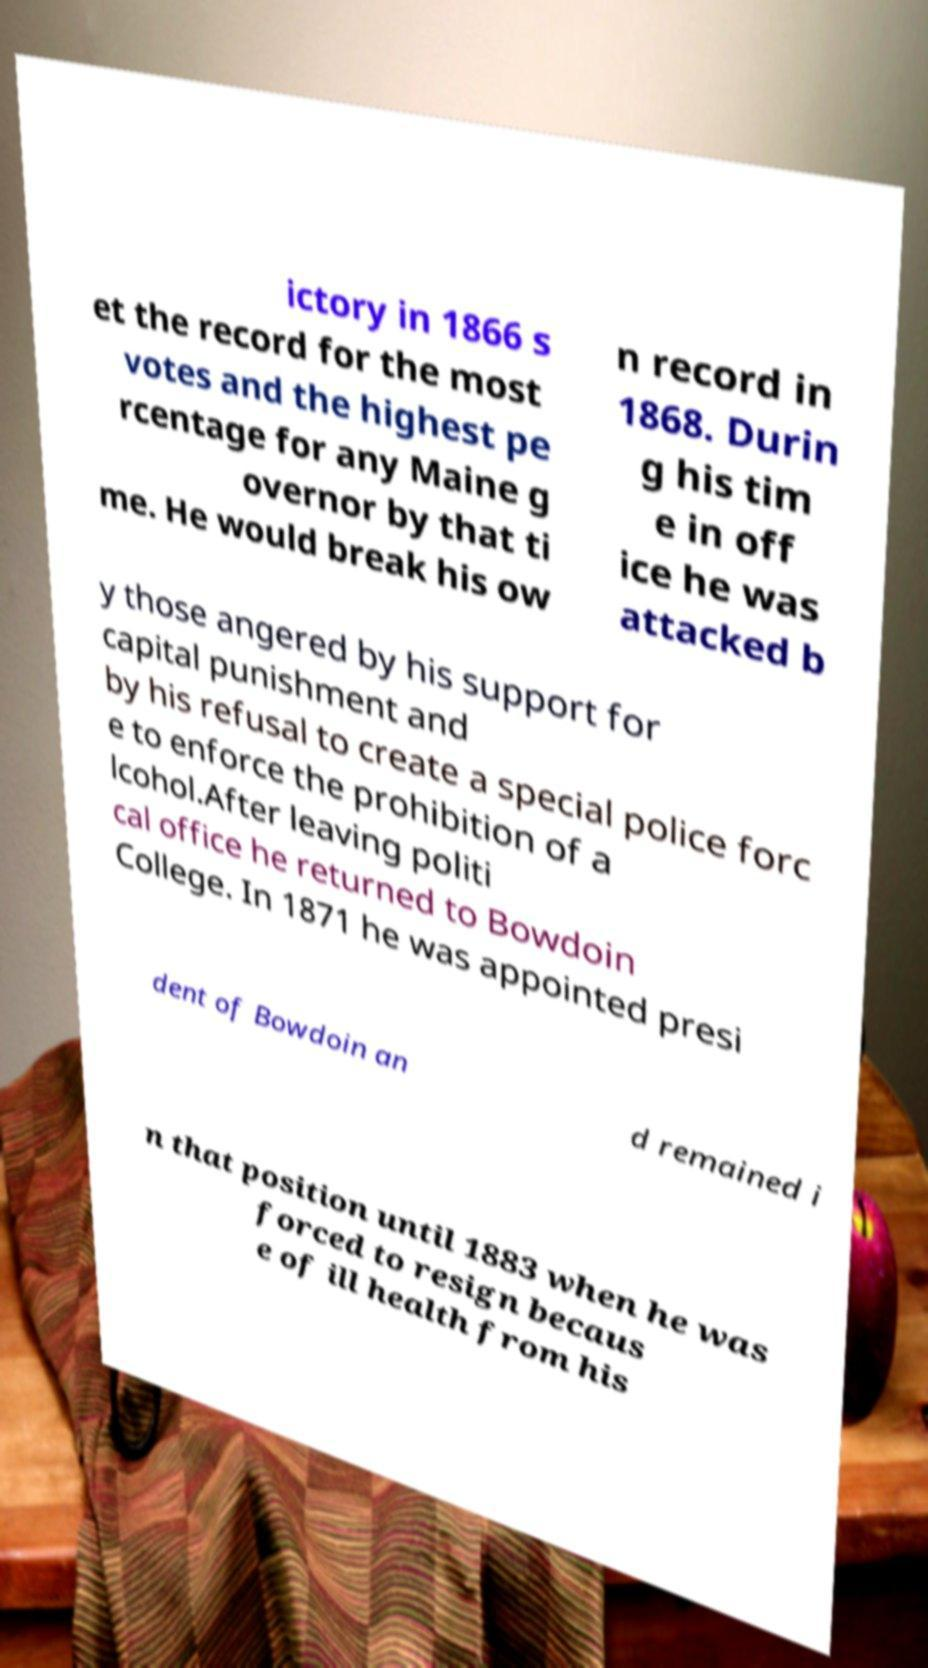Can you read and provide the text displayed in the image?This photo seems to have some interesting text. Can you extract and type it out for me? ictory in 1866 s et the record for the most votes and the highest pe rcentage for any Maine g overnor by that ti me. He would break his ow n record in 1868. Durin g his tim e in off ice he was attacked b y those angered by his support for capital punishment and by his refusal to create a special police forc e to enforce the prohibition of a lcohol.After leaving politi cal office he returned to Bowdoin College. In 1871 he was appointed presi dent of Bowdoin an d remained i n that position until 1883 when he was forced to resign becaus e of ill health from his 